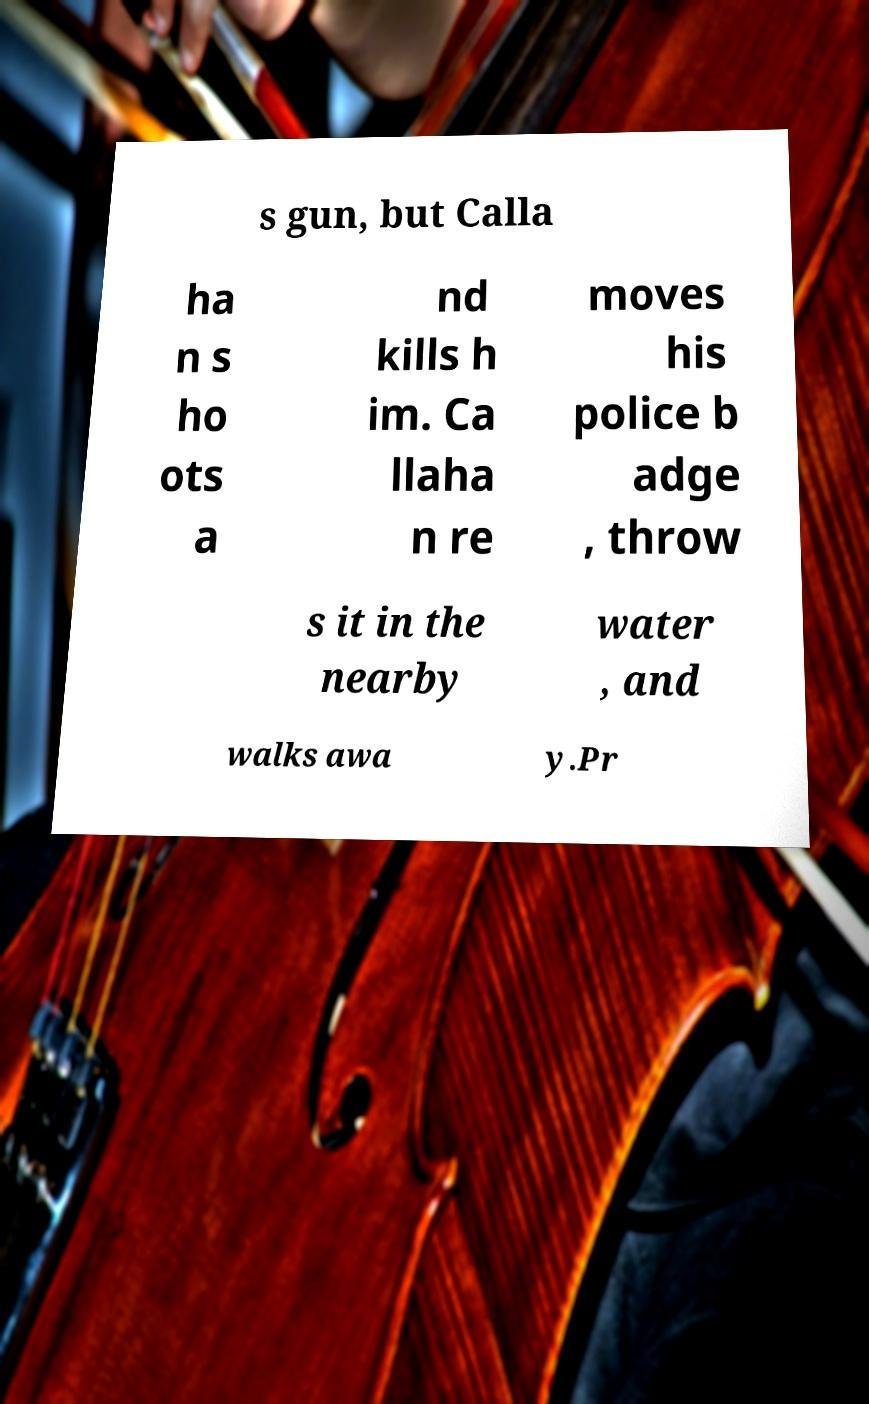For documentation purposes, I need the text within this image transcribed. Could you provide that? s gun, but Calla ha n s ho ots a nd kills h im. Ca llaha n re moves his police b adge , throw s it in the nearby water , and walks awa y.Pr 